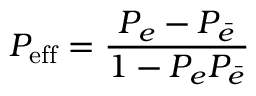<formula> <loc_0><loc_0><loc_500><loc_500>P _ { e f f } = \frac { P _ { e } - P _ { \bar { e } } } { 1 - P _ { e } P _ { \bar { e } } }</formula> 